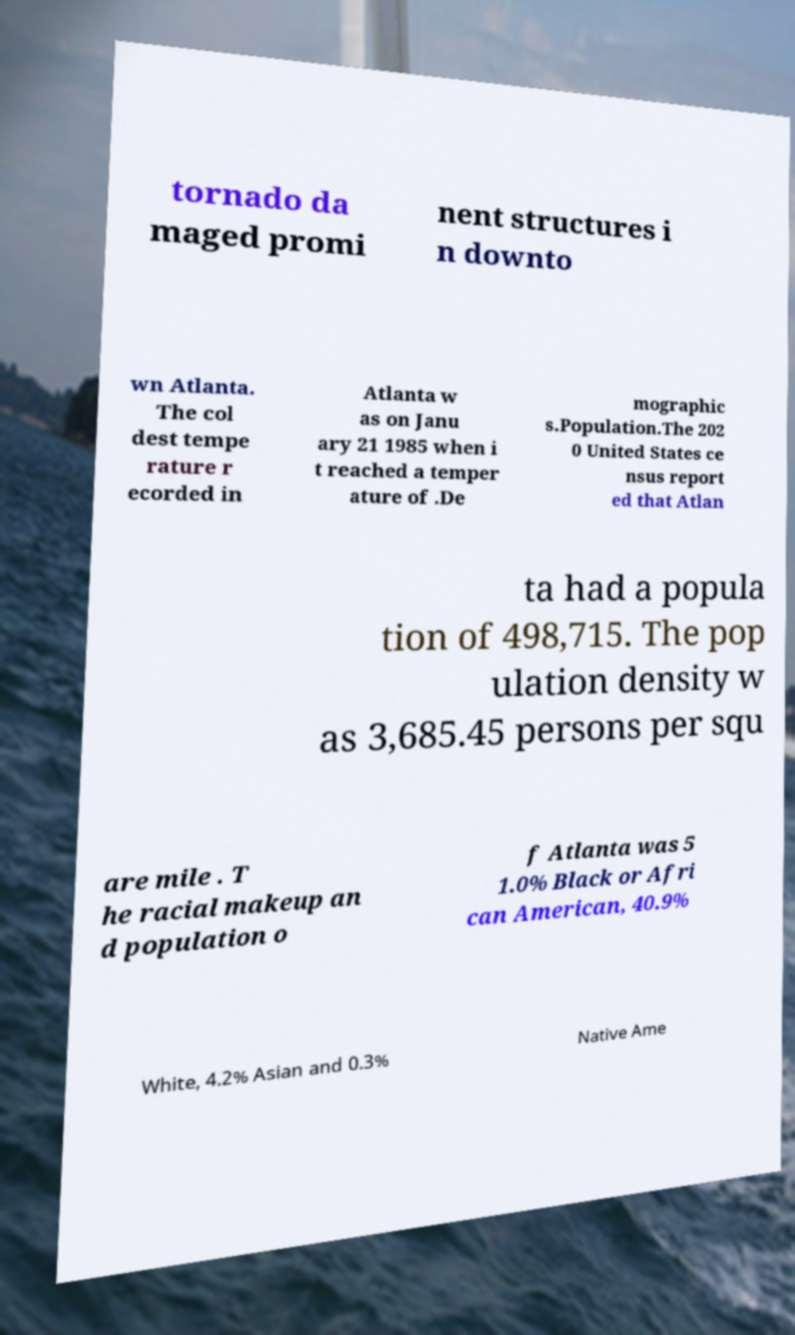I need the written content from this picture converted into text. Can you do that? tornado da maged promi nent structures i n downto wn Atlanta. The col dest tempe rature r ecorded in Atlanta w as on Janu ary 21 1985 when i t reached a temper ature of .De mographic s.Population.The 202 0 United States ce nsus report ed that Atlan ta had a popula tion of 498,715. The pop ulation density w as 3,685.45 persons per squ are mile . T he racial makeup an d population o f Atlanta was 5 1.0% Black or Afri can American, 40.9% White, 4.2% Asian and 0.3% Native Ame 